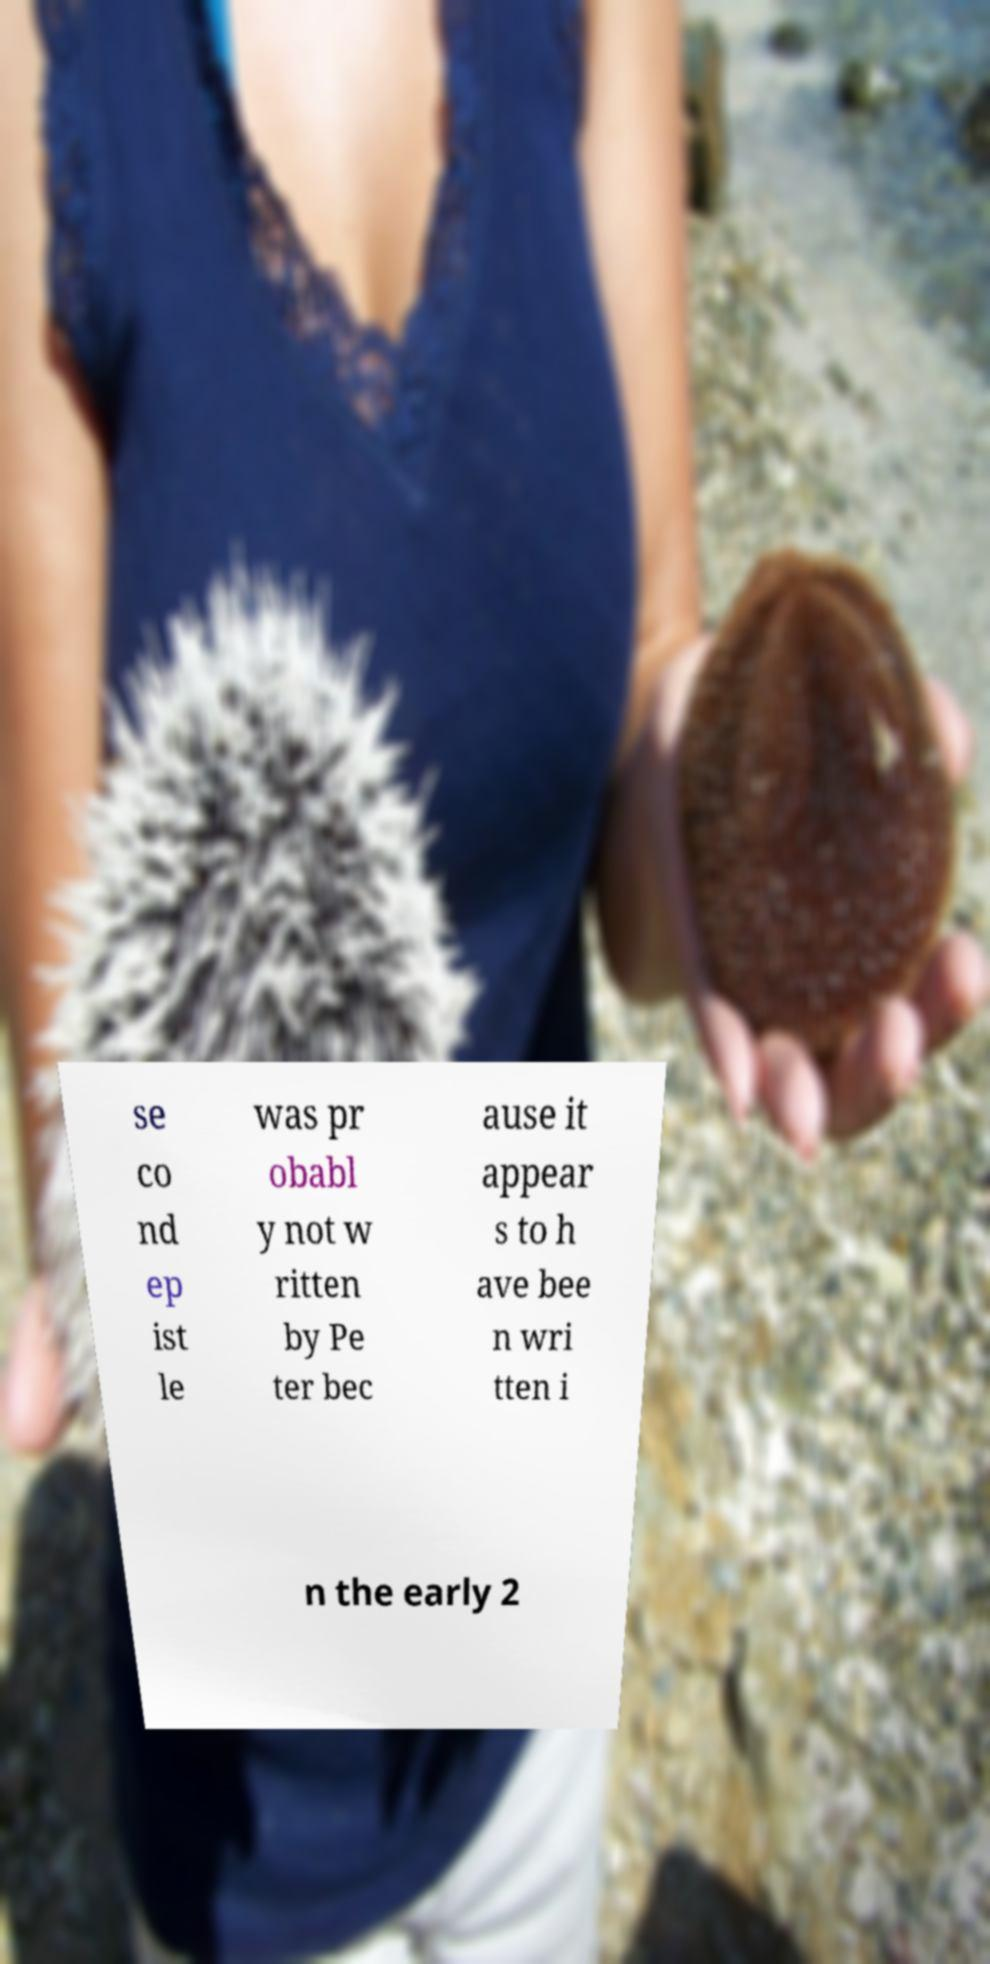For documentation purposes, I need the text within this image transcribed. Could you provide that? se co nd ep ist le was pr obabl y not w ritten by Pe ter bec ause it appear s to h ave bee n wri tten i n the early 2 